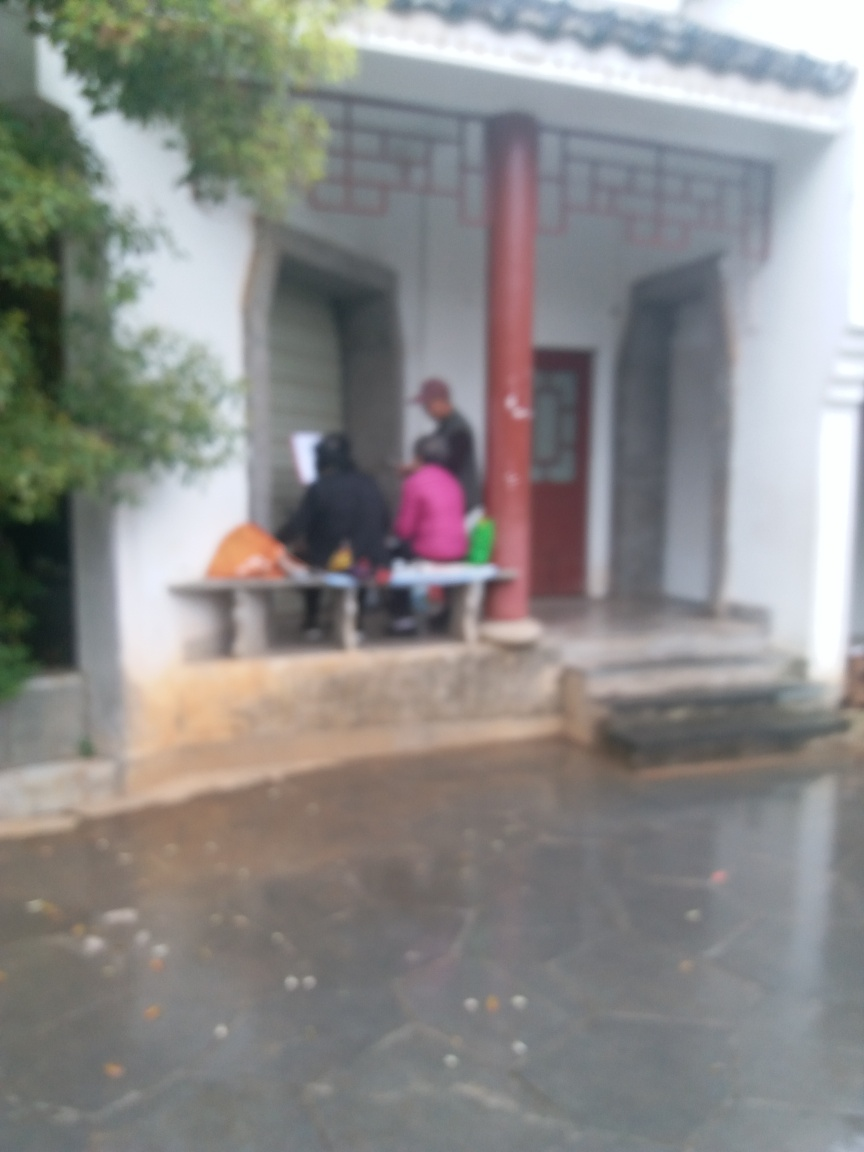Can you describe the setting depicted in this blurry image? Despite the blurriness, it appears to be an outdoor scene, possibly a traditional building with a porch, where several individuals are gathered, possibly engaging in a conversation or waiting. 